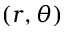<formula> <loc_0><loc_0><loc_500><loc_500>( r , \theta )</formula> 